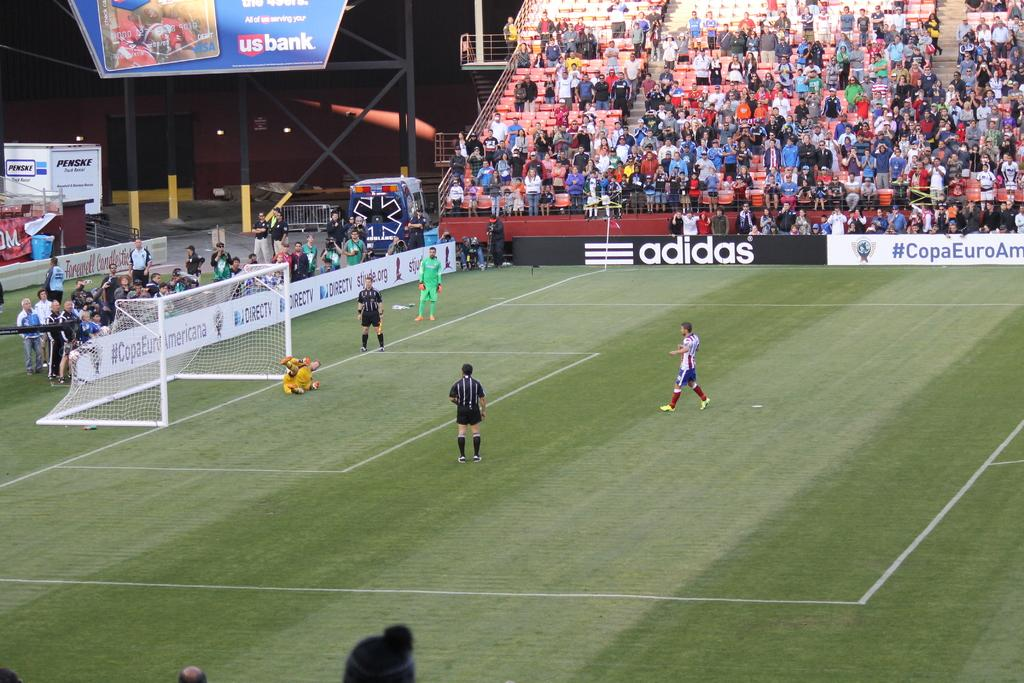<image>
Write a terse but informative summary of the picture. one of the sponsors of the soccer game is adidas 